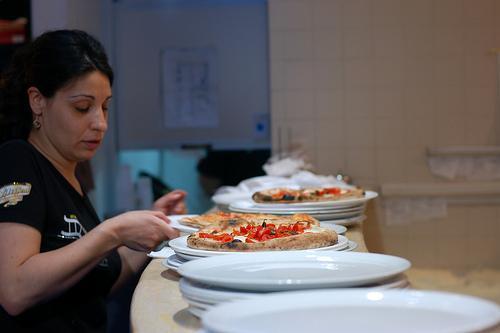How many plates have food on them?
Give a very brief answer. 3. 